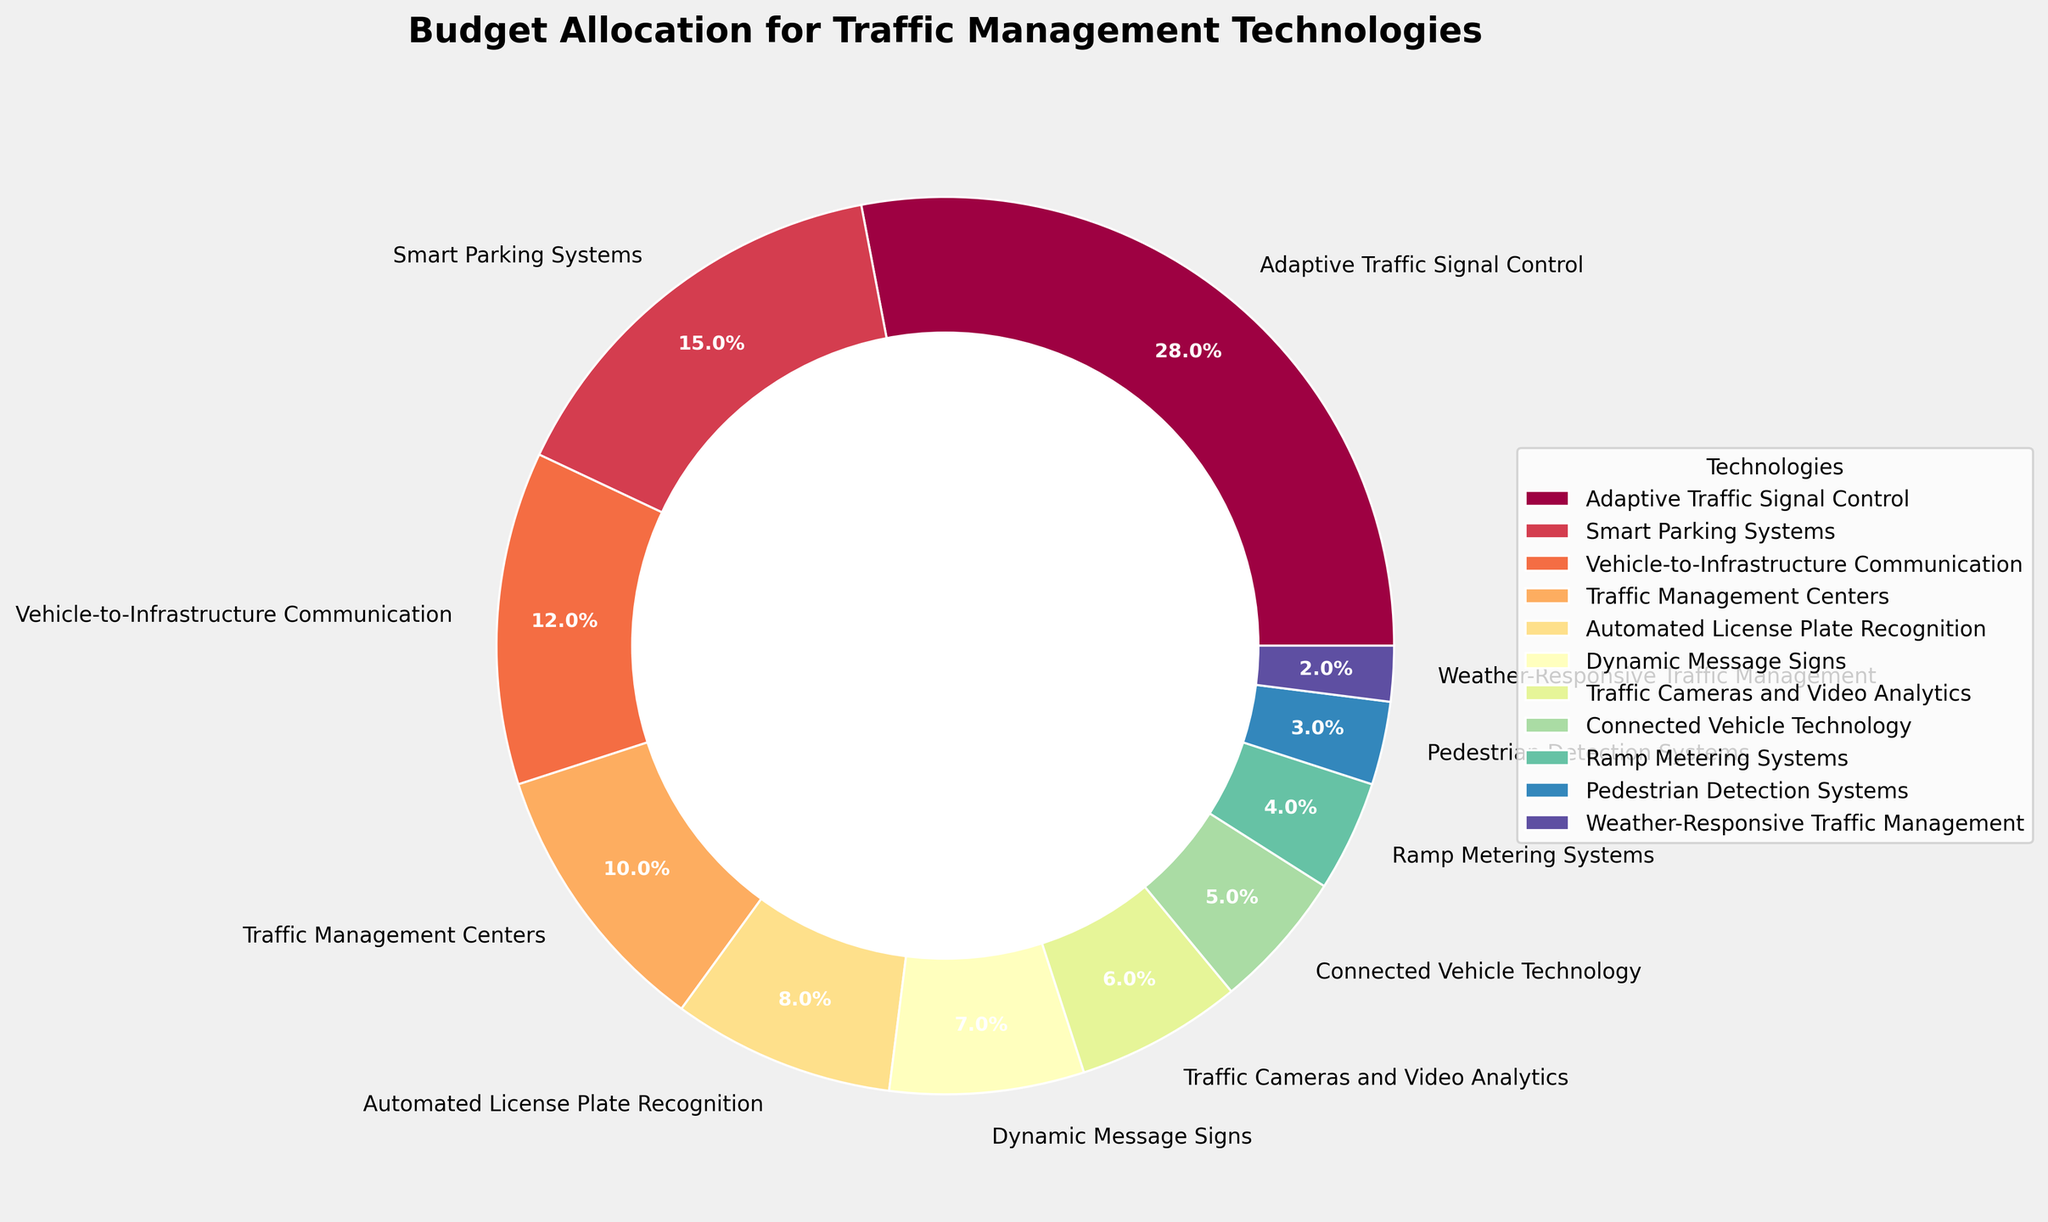Which technology receives the largest budget allocation? The technology with the largest budget allocation is represented by the biggest section in the pie chart. A quick look at the chart shows that Adaptive Traffic Signal Control has the largest section.
Answer: Adaptive Traffic Signal Control How much more budget is allocated to Adaptive Traffic Signal Control compared to Smart Parking Systems? To find the difference in budget allocations between Adaptive Traffic Signal Control and Smart Parking Systems, subtract the percentage allocated to Smart Parking Systems from the percentage allocated to Adaptive Traffic Signal Control: 28% - 15%.
Answer: 13% What is the combined budget allocation for Vehicle-to-Infrastructure Communication and Traffic Management Centers? Add the budget allocations of Vehicle-to-Infrastructure Communication and Traffic Management Centers together: 12% + 10%.
Answer: 22% Which technology has a greater budget allocation: Automated License Plate Recognition or Dynamic Message Signs? Compare the budget allocations for Automated License Plate Recognition (8%) and Dynamic Message Signs (7%). Since 8% is greater than 7%, Automated License Plate Recognition has a greater budget allocation.
Answer: Automated License Plate Recognition What is the total budget allocation for all technologies that individually receive less than 10%? Add the percentages for all technologies with less than 10% allocation: 8% + 7% + 6% + 5% + 4% + 3% + 2% = 35%.
Answer: 35% What is the difference in budget allocation between Traffic Cameras and Video Analytics and Connected Vehicle Technology? Subtract the budget allocation for Connected Vehicle Technology from that of Traffic Cameras and Video Analytics: 6% - 5%.
Answer: 1% Is the budget allocation for Pedestrian Detection Systems greater than or less than the budget allocation for Ramp Metering Systems? Compare the budget allocations for Pedestrian Detection Systems (3%) and Ramp Metering Systems (4%). Since 3% is less than 4%, the budget allocation for Pedestrian Detection Systems is less.
Answer: Less How does the size of the section for Weather-Responsive Traffic Management compare visually to the section for Adaptive Traffic Signal Control? The section for Weather-Responsive Traffic Management is significantly smaller than the section for Adaptive Traffic Signal Control, indicating a much smaller budget allocation.
Answer: Significantly smaller What is the average budget allocation for all technologies receiving at least 10%? First, identify the percentages for technologies receiving at least 10%: Adaptive Traffic Signal Control (28%), Smart Parking Systems (15%), Vehicle-to-Infrastructure Communication (12%), and Traffic Management Centers (10%). Add these together: 28% + 15% + 12% + 10% = 65%, then divide by the number of technologies (4): 65% / 4.
Answer: 16.25% Among Traffic Management Centers and Smart Parking Systems, which receives a higher budget allocation and by how much? Compare the budget allocations for Traffic Management Centers (10%) and Smart Parking Systems (15%). Subtract 10% from 15%: 15% - 10%.
Answer: Smart Parking Systems by 5% 